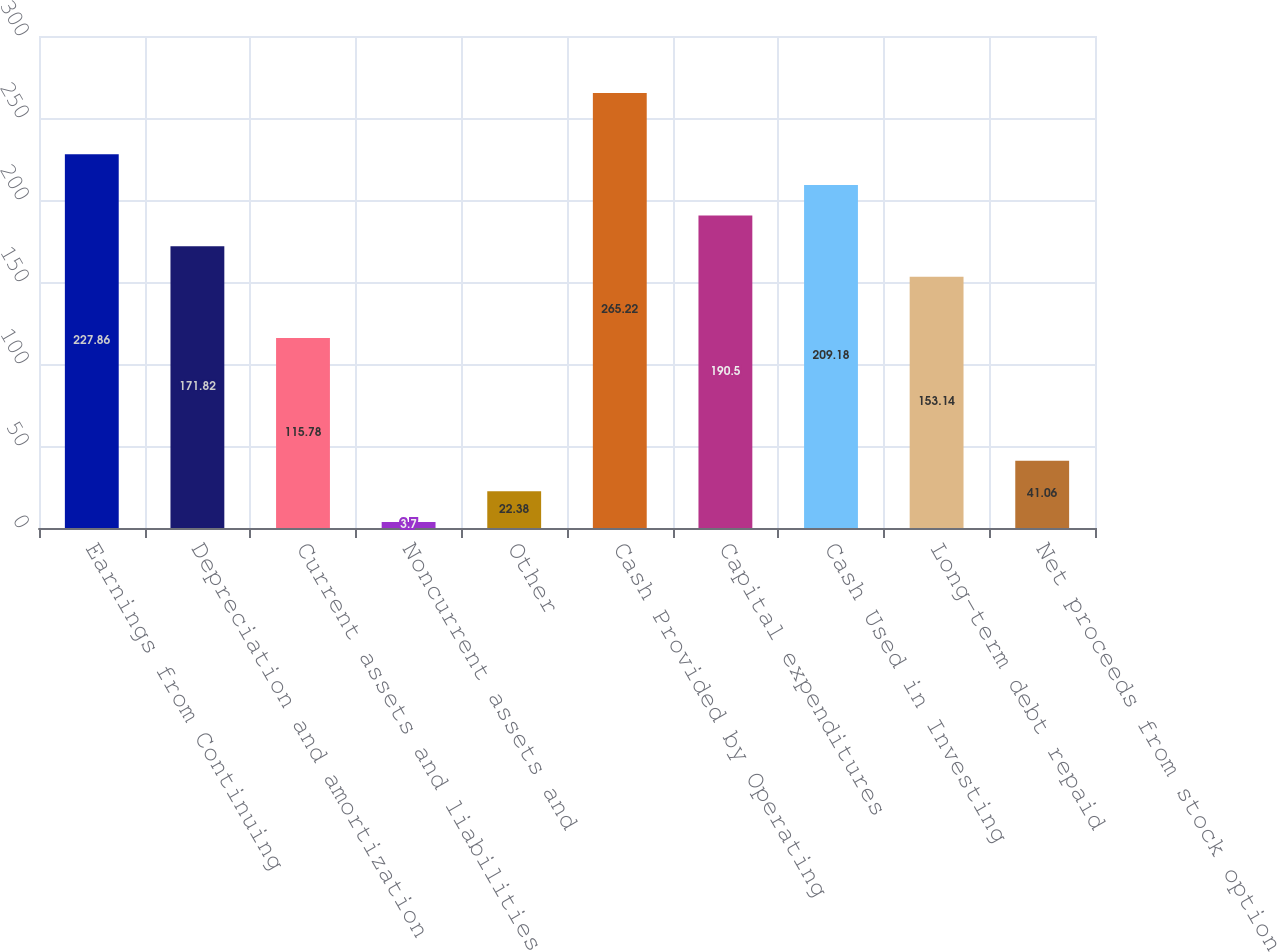<chart> <loc_0><loc_0><loc_500><loc_500><bar_chart><fcel>Earnings from Continuing<fcel>Depreciation and amortization<fcel>Current assets and liabilities<fcel>Noncurrent assets and<fcel>Other<fcel>Cash Provided by Operating<fcel>Capital expenditures<fcel>Cash Used in Investing<fcel>Long-term debt repaid<fcel>Net proceeds from stock option<nl><fcel>227.86<fcel>171.82<fcel>115.78<fcel>3.7<fcel>22.38<fcel>265.22<fcel>190.5<fcel>209.18<fcel>153.14<fcel>41.06<nl></chart> 